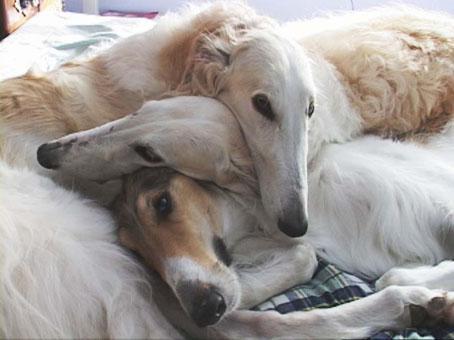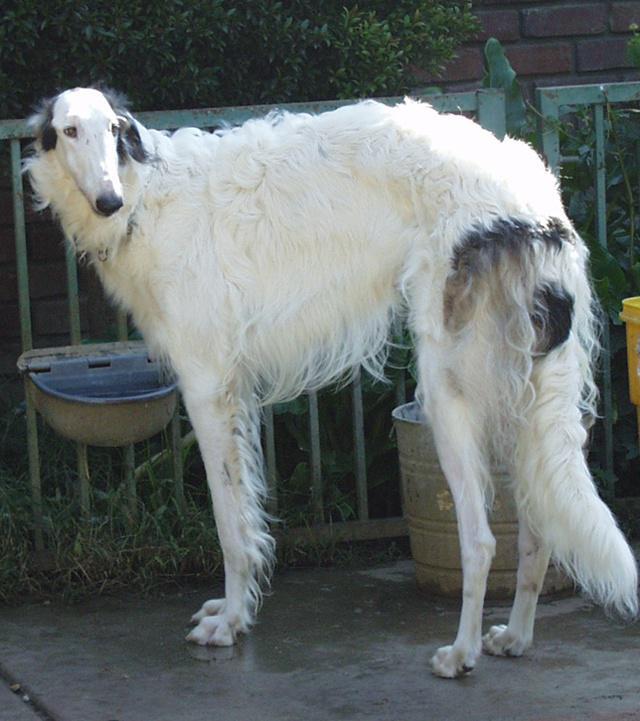The first image is the image on the left, the second image is the image on the right. Assess this claim about the two images: "The left image contains three dogs.". Correct or not? Answer yes or no. Yes. The first image is the image on the left, the second image is the image on the right. Given the left and right images, does the statement "The right image contains one hound standing in profile with its body turned leftward, and the left image contains three hounds with their heads not all pointed in the same direction." hold true? Answer yes or no. Yes. 